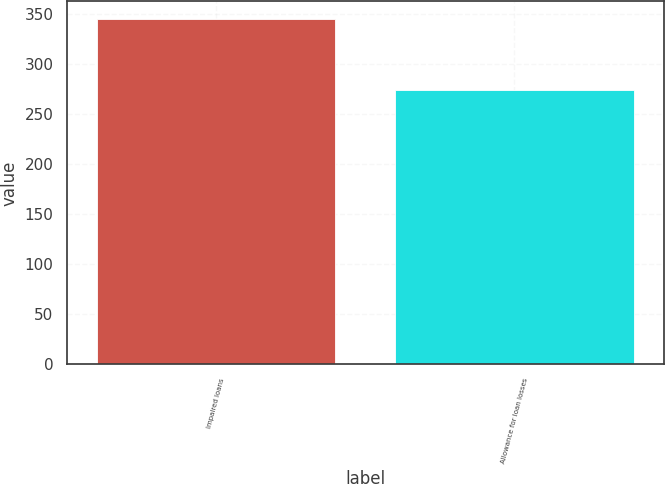Convert chart to OTSL. <chart><loc_0><loc_0><loc_500><loc_500><bar_chart><fcel>Impaired loans<fcel>Allowance for loan losses<nl><fcel>345<fcel>274<nl></chart> 